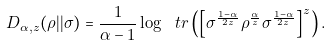Convert formula to latex. <formula><loc_0><loc_0><loc_500><loc_500>D _ { \alpha , z } ( \rho | | \sigma ) = \frac { 1 } { \alpha - 1 } \log \ t r \left ( \left [ \sigma ^ { \frac { 1 - \alpha } { 2 z } } \rho ^ { \frac { \alpha } { z } } \sigma ^ { \frac { 1 - \alpha } { 2 z } } \right ] ^ { z } \right ) .</formula> 